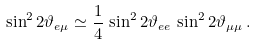Convert formula to latex. <formula><loc_0><loc_0><loc_500><loc_500>\sin ^ { 2 } 2 \vartheta _ { e \mu } \simeq \frac { 1 } { 4 } \, \sin ^ { 2 } 2 \vartheta _ { e e } \, \sin ^ { 2 } 2 \vartheta _ { \mu \mu } \, .</formula> 